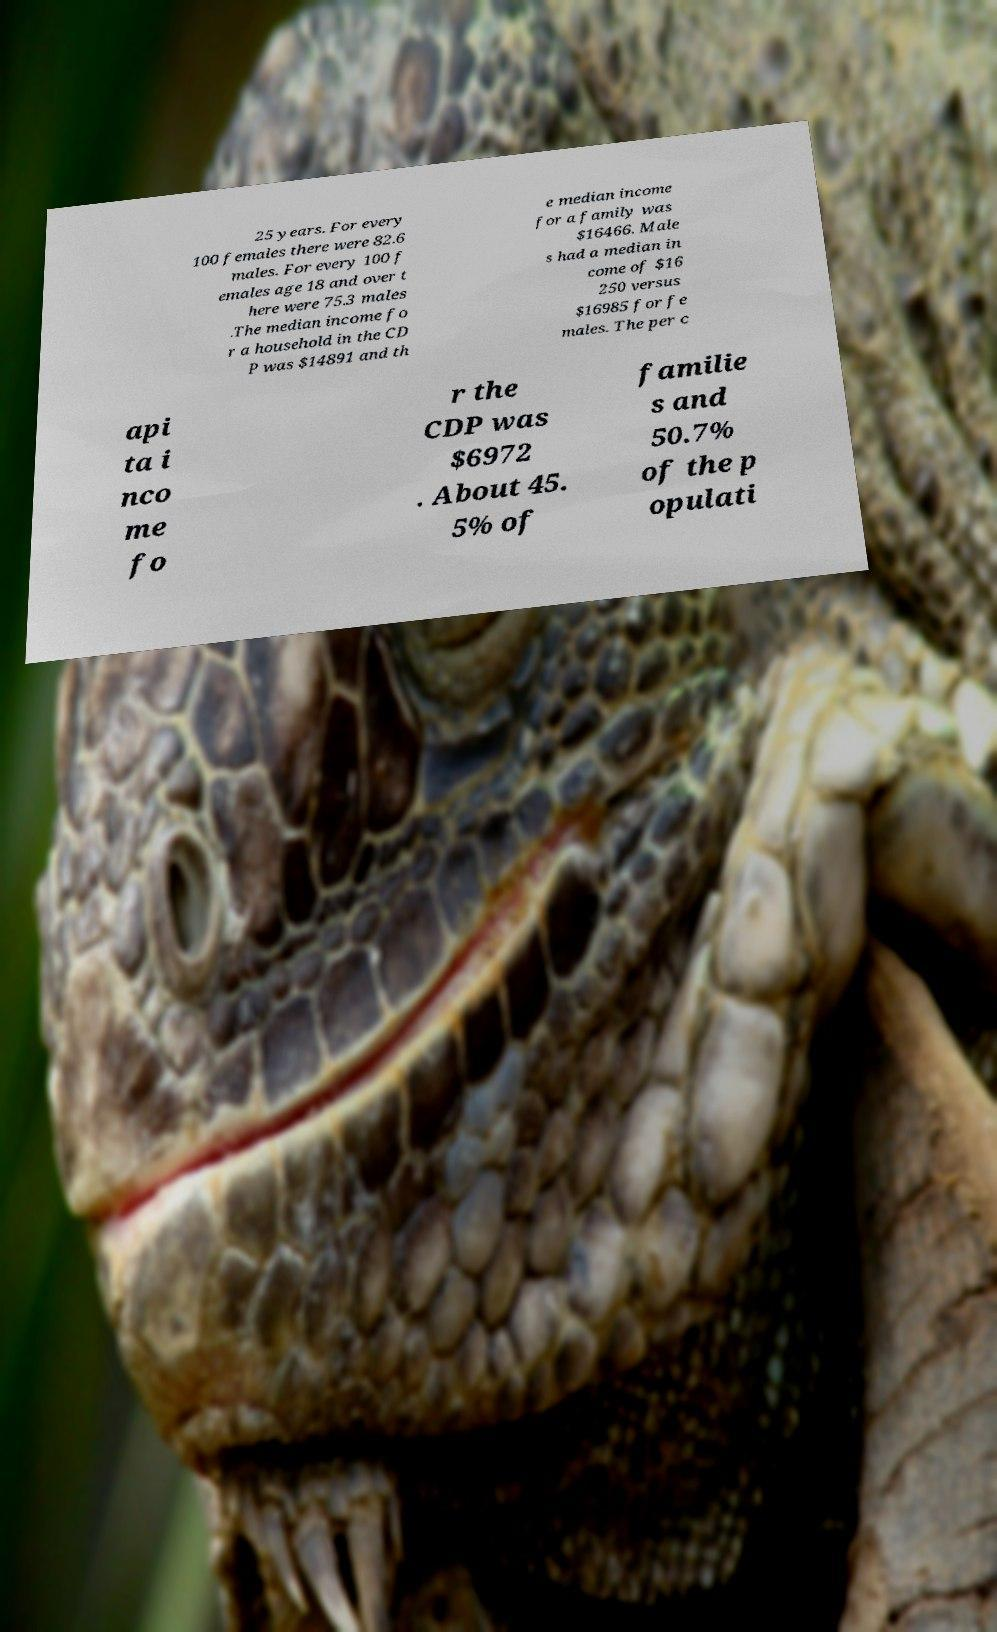Could you extract and type out the text from this image? 25 years. For every 100 females there were 82.6 males. For every 100 f emales age 18 and over t here were 75.3 males .The median income fo r a household in the CD P was $14891 and th e median income for a family was $16466. Male s had a median in come of $16 250 versus $16985 for fe males. The per c api ta i nco me fo r the CDP was $6972 . About 45. 5% of familie s and 50.7% of the p opulati 